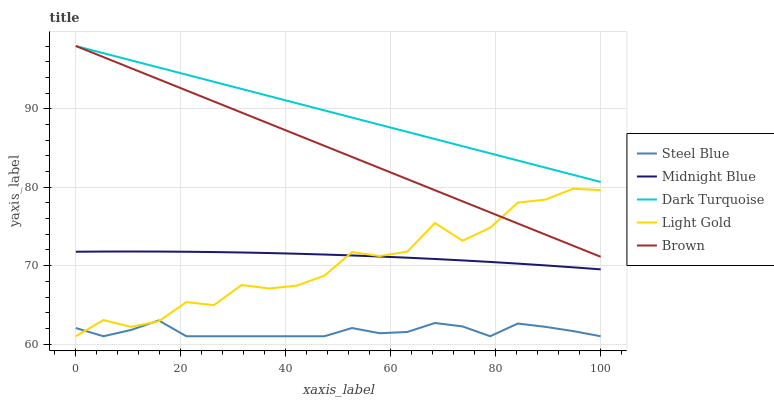Does Steel Blue have the minimum area under the curve?
Answer yes or no. Yes. Does Dark Turquoise have the maximum area under the curve?
Answer yes or no. Yes. Does Light Gold have the minimum area under the curve?
Answer yes or no. No. Does Light Gold have the maximum area under the curve?
Answer yes or no. No. Is Brown the smoothest?
Answer yes or no. Yes. Is Light Gold the roughest?
Answer yes or no. Yes. Is Steel Blue the smoothest?
Answer yes or no. No. Is Steel Blue the roughest?
Answer yes or no. No. Does Light Gold have the lowest value?
Answer yes or no. Yes. Does Brown have the lowest value?
Answer yes or no. No. Does Brown have the highest value?
Answer yes or no. Yes. Does Light Gold have the highest value?
Answer yes or no. No. Is Light Gold less than Dark Turquoise?
Answer yes or no. Yes. Is Brown greater than Steel Blue?
Answer yes or no. Yes. Does Light Gold intersect Steel Blue?
Answer yes or no. Yes. Is Light Gold less than Steel Blue?
Answer yes or no. No. Is Light Gold greater than Steel Blue?
Answer yes or no. No. Does Light Gold intersect Dark Turquoise?
Answer yes or no. No. 